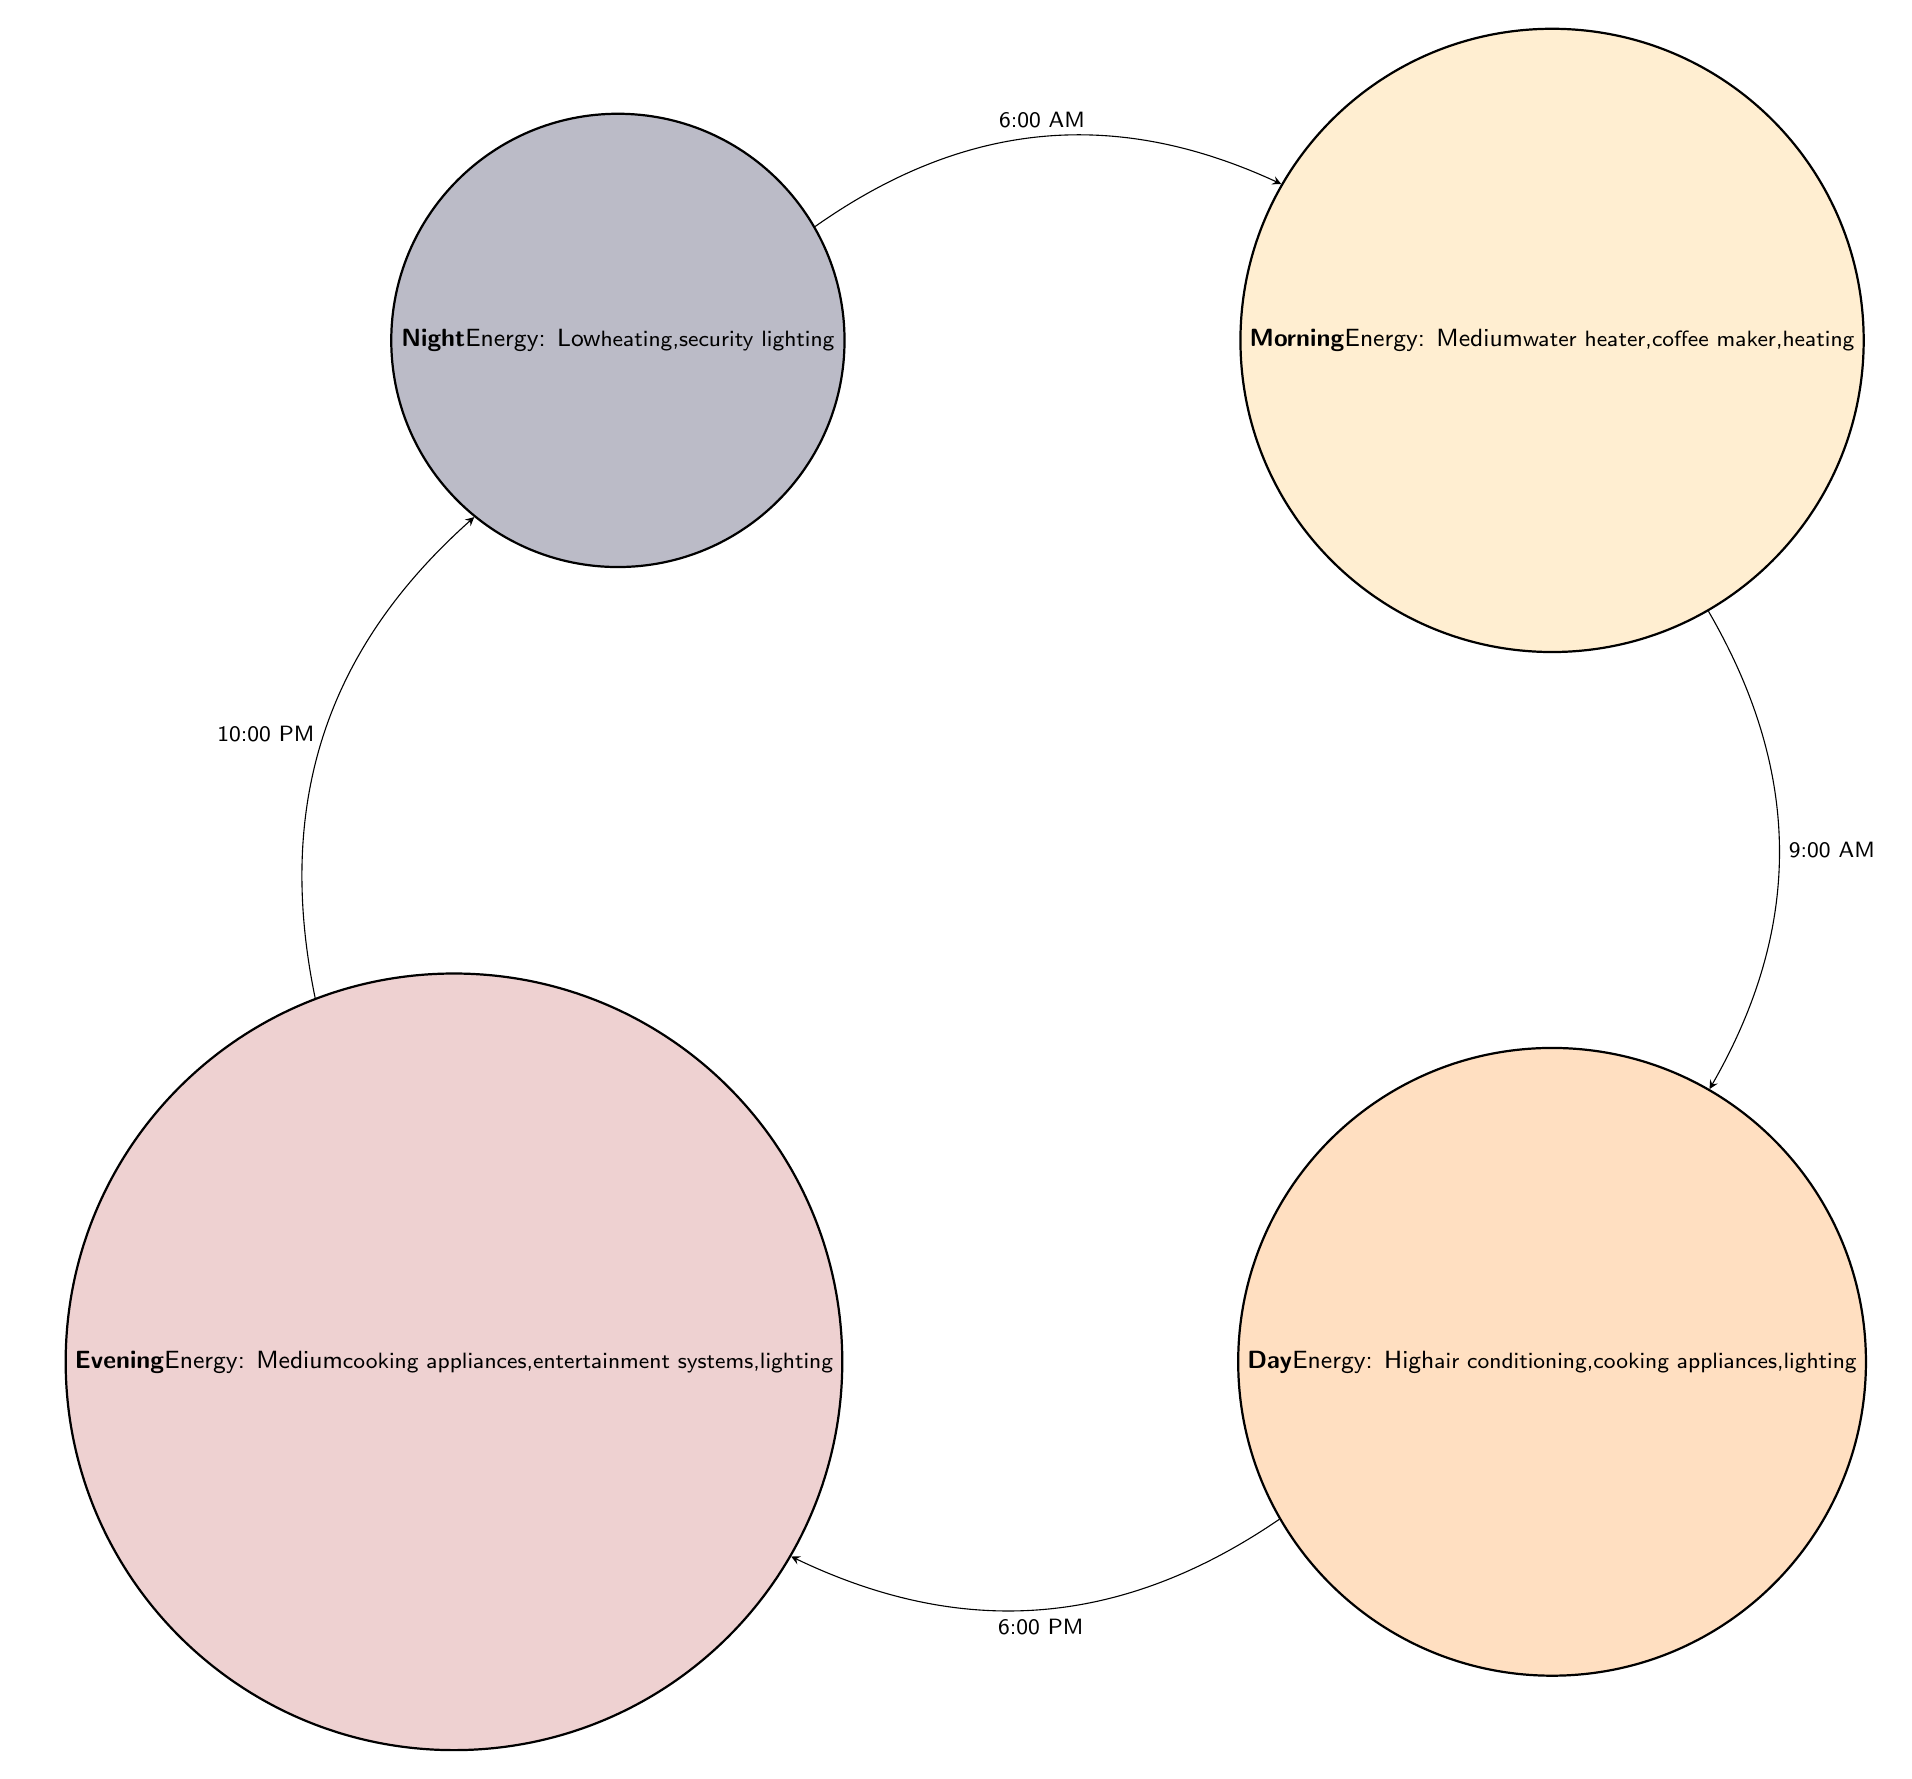What are the energy consumption levels for the Night state? The Night state in the diagram explicitly states that the energy consumption is "low."
Answer: low What activities occur during the Day state? The diagram lists the activities in the Day state as "air conditioning," "cooking appliances," and "lighting."
Answer: air conditioning, cooking appliances, lighting At what time does the transition from Morning to Day occur? According to the diagram, the transition occurs at "9:00 AM."
Answer: 9:00 AM How many states are presented in the diagram? The diagram shows four states: Night, Morning, Day, and Evening. Counting these states gives us a total of four.
Answer: 4 Which state has the highest energy consumption? The Day state is defined in the diagram as having "high" energy consumption, which is higher than the other states.
Answer: high What activities are performed during the Evening state? The Evening state features activities including "cooking appliances," "entertainment systems," and "lighting," as shown in the diagram.
Answer: cooking appliances, entertainment systems, lighting What is the trigger that leads from Evening to Night? The diagram indicates that the trigger for the transition from Evening to Night is "10:00 PM."
Answer: 10:00 PM Which states have medium energy consumption? The Morning and Evening states exhibit "medium" energy consumption levels, as stated in the diagram.
Answer: Morning, Evening What is the last state before Night in the transition flow? The state before Night is Evening, which transitions back to Night at "10:00 PM."
Answer: Evening 